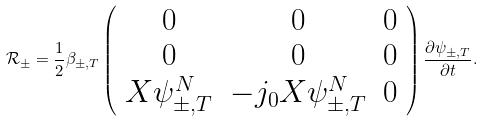<formula> <loc_0><loc_0><loc_500><loc_500>\mathcal { R } _ { \pm } = \frac { 1 } { 2 } \beta _ { \pm , T } \left ( \begin{array} { c c c } 0 & 0 & 0 \\ 0 & 0 & 0 \\ X \psi _ { \pm , T } ^ { N } & - j _ { 0 } X \psi _ { \pm , T } ^ { N } & 0 \end{array} \right ) \frac { \partial \psi _ { \pm , T } } { \partial t } .</formula> 